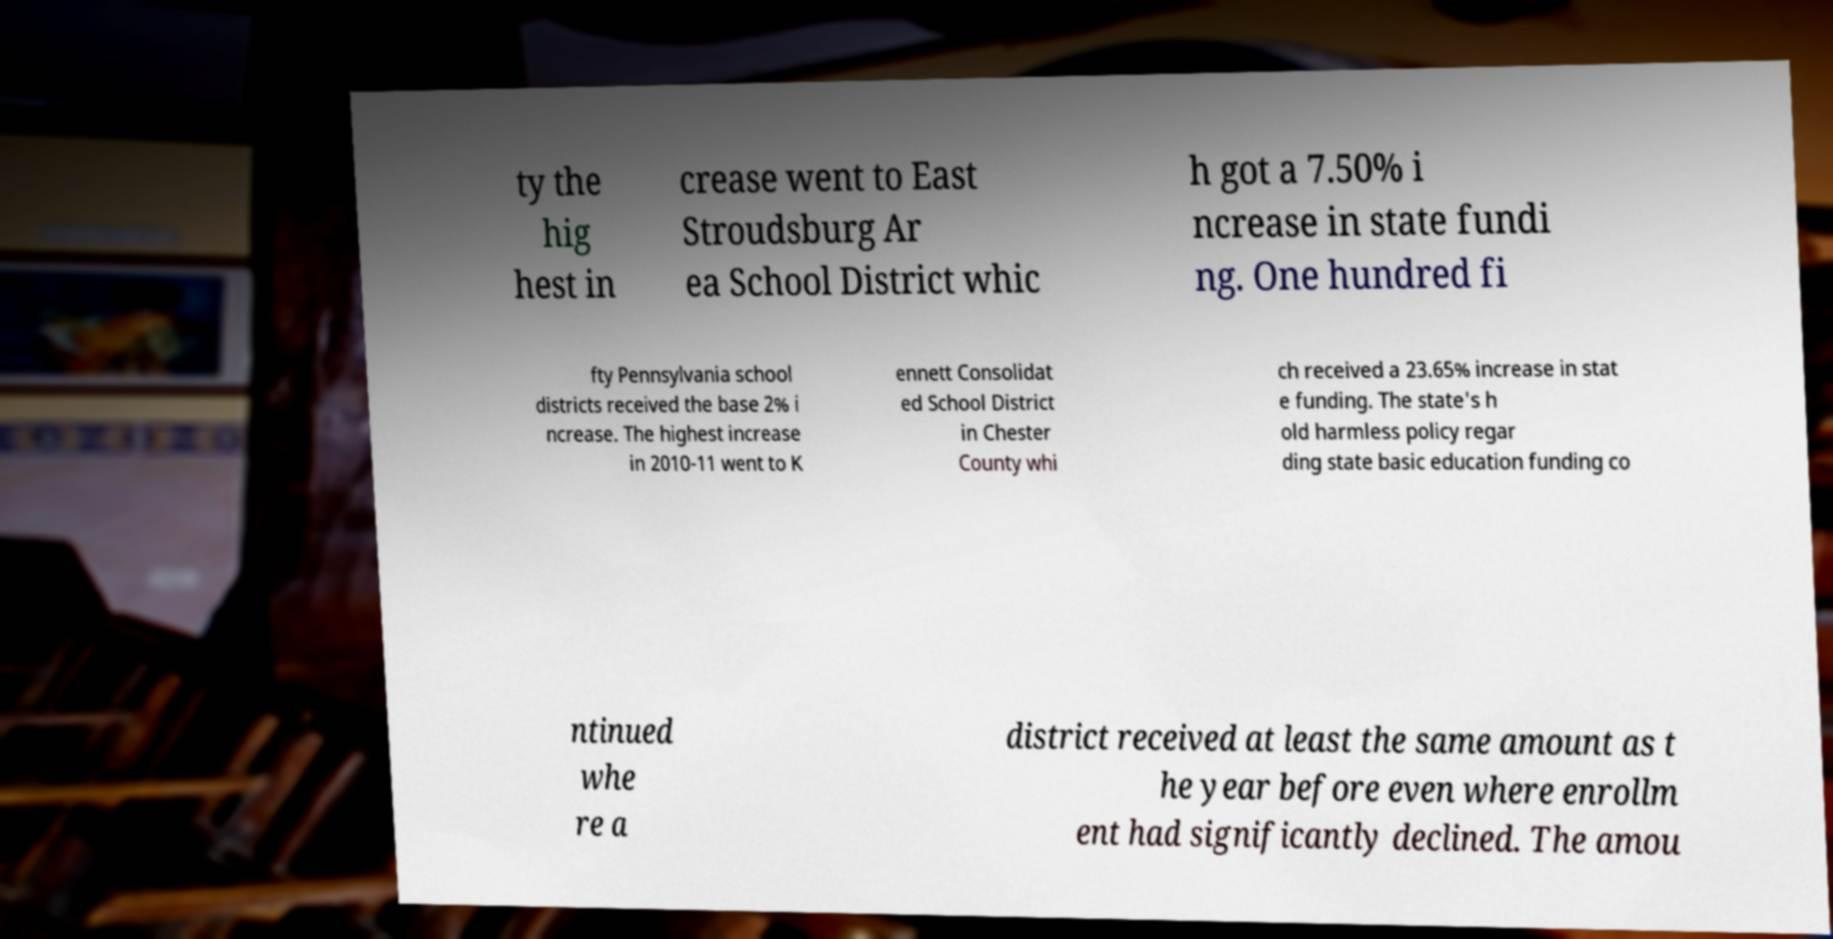Please read and relay the text visible in this image. What does it say? ty the hig hest in crease went to East Stroudsburg Ar ea School District whic h got a 7.50% i ncrease in state fundi ng. One hundred fi fty Pennsylvania school districts received the base 2% i ncrease. The highest increase in 2010-11 went to K ennett Consolidat ed School District in Chester County whi ch received a 23.65% increase in stat e funding. The state's h old harmless policy regar ding state basic education funding co ntinued whe re a district received at least the same amount as t he year before even where enrollm ent had significantly declined. The amou 